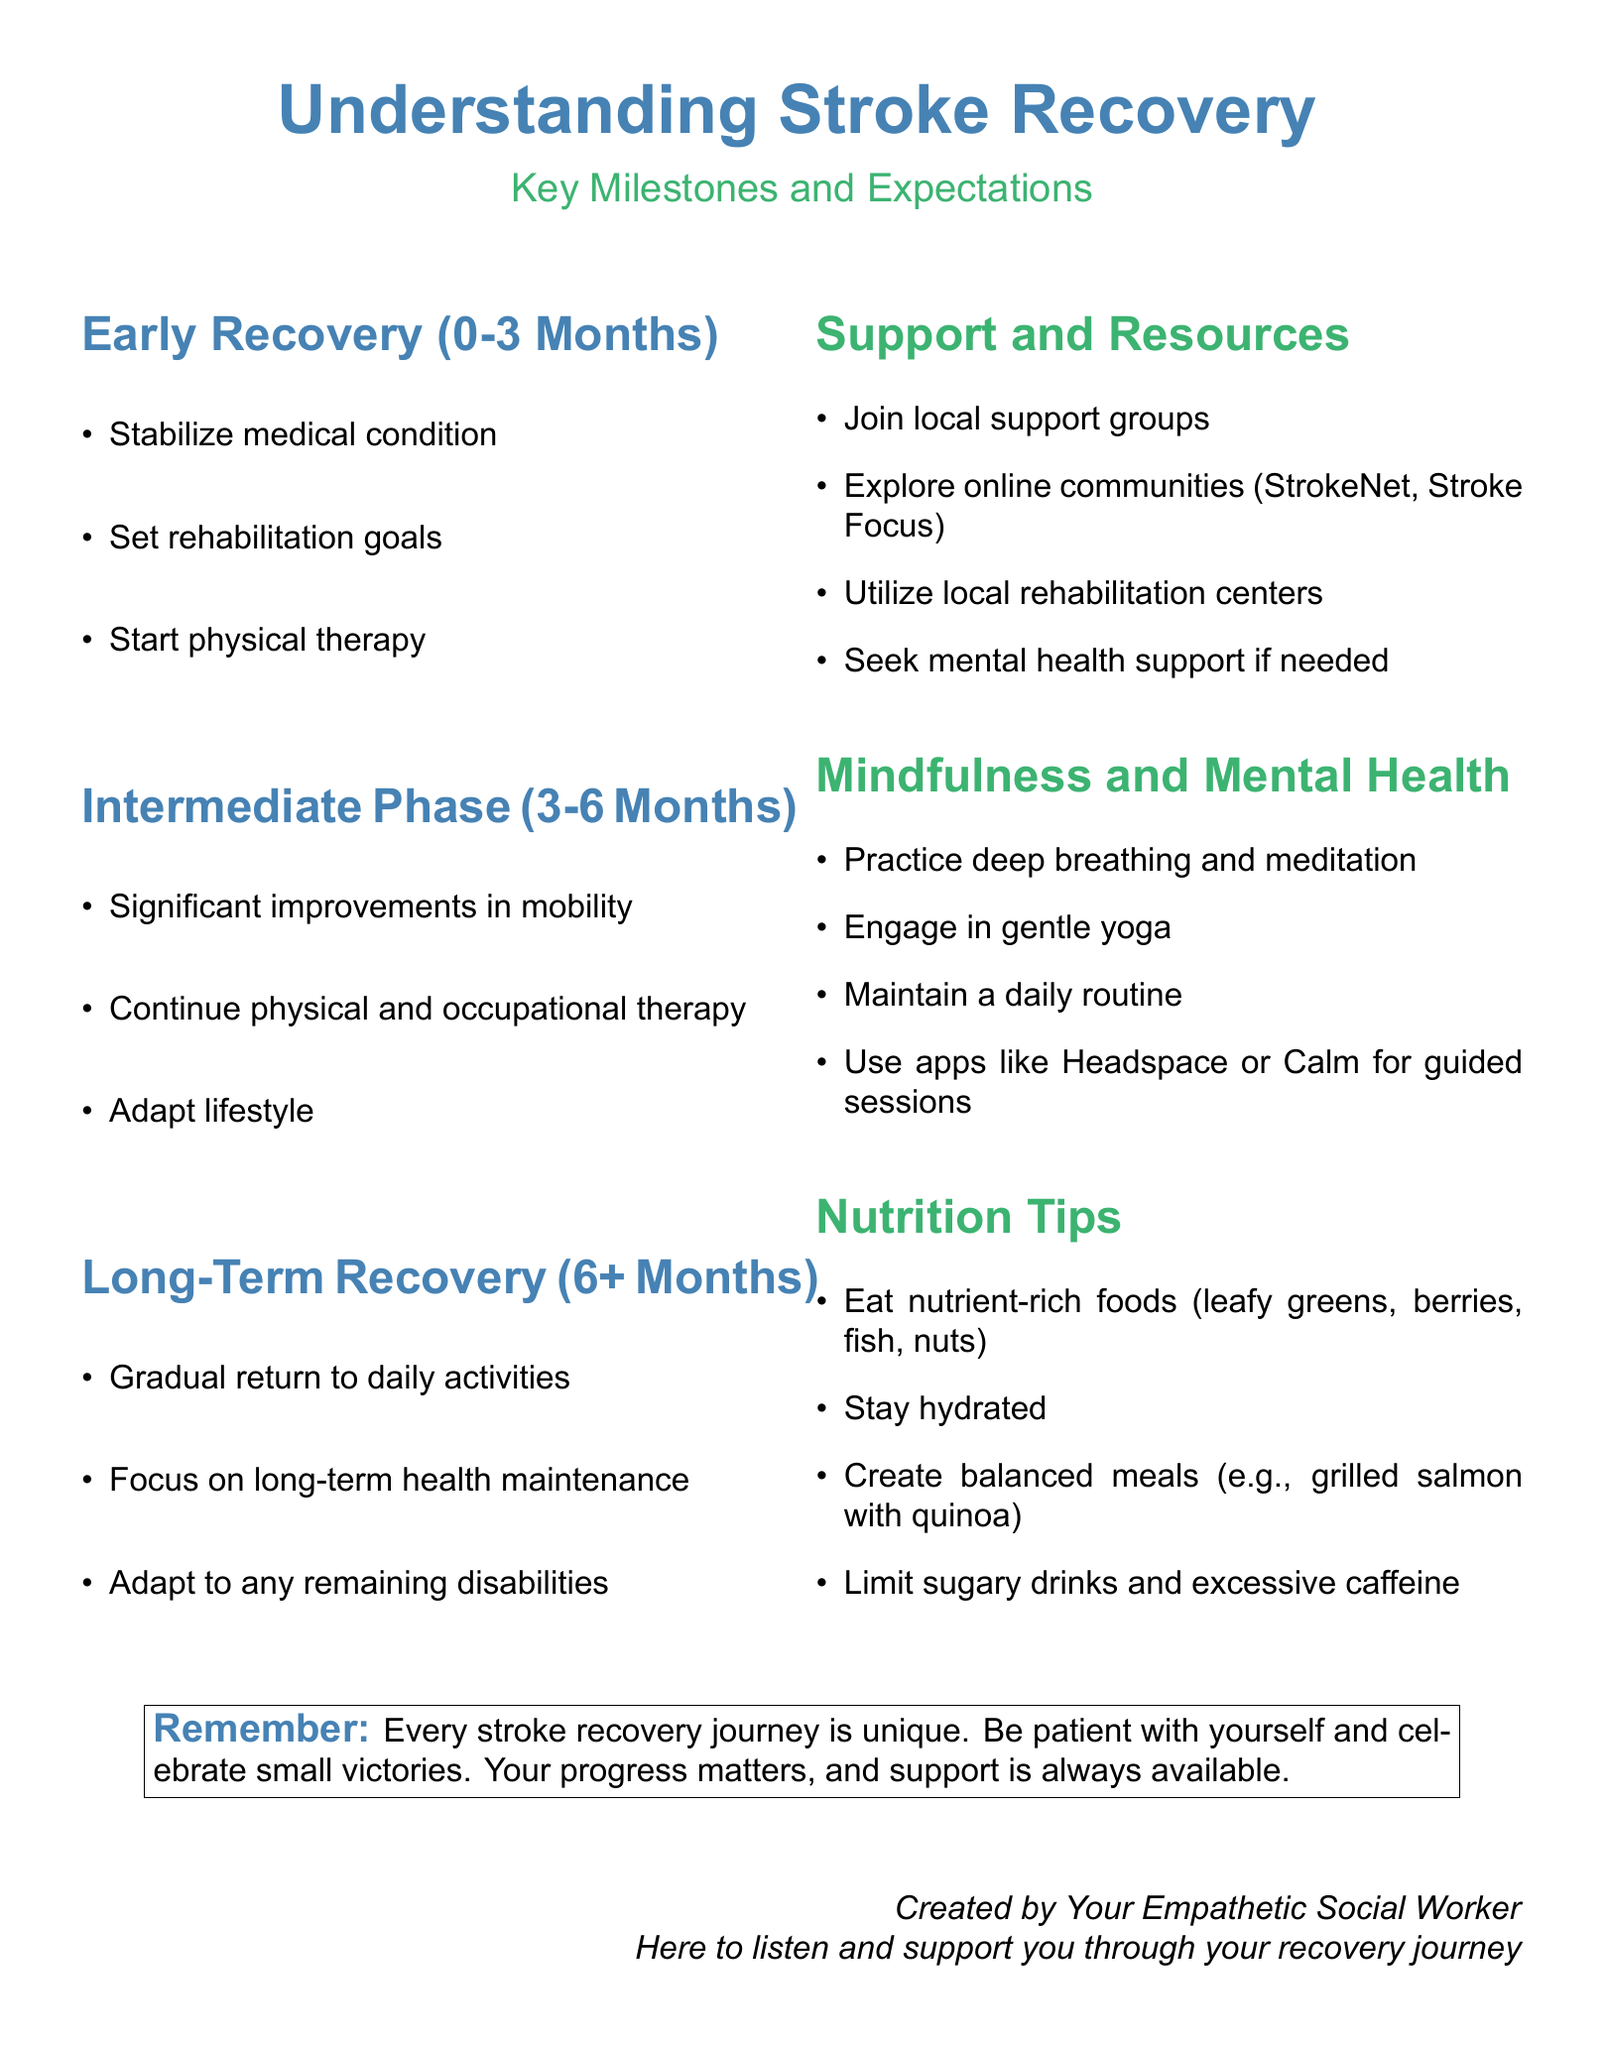What are the key phases of stroke recovery? The document lists Early Recovery, Intermediate Phase, and Long-Term Recovery as the key phases of stroke recovery.
Answer: Early Recovery, Intermediate Phase, Long-Term Recovery What is the time frame for Early Recovery? Early Recovery is specified in the document as lasting from 0 to 3 months.
Answer: 0-3 Months What is one activity recommended during the Intermediate Phase? The document suggests that significant improvements in mobility occur during the Intermediate Phase.
Answer: Significant improvements in mobility How long is the Long-Term Recovery phase? Long-Term Recovery starts after 6 months and continues indefinitely.
Answer: 6+ Months What is one support option mentioned for stroke survivors? The document lists joining local support groups as a support option for stroke survivors.
Answer: Join local support groups What type of exercise is suggested for mental health during recovery? The document recommends engaging in gentle yoga as a mindfulness practice.
Answer: Gentle yoga What is a nutritional tip provided in the flyer? The flyer advises eating nutrient-rich foods such as leafy greens, berries, fish, and nuts.
Answer: Eat nutrient-rich foods What does the document encourage individuals to celebrate? The document emphasizes celebrating small victories during the recovery journey.
Answer: Small victories Who created the flyer? The document credits the creation to an empathetic social worker who supports stroke recovery.
Answer: Your Empathetic Social Worker 